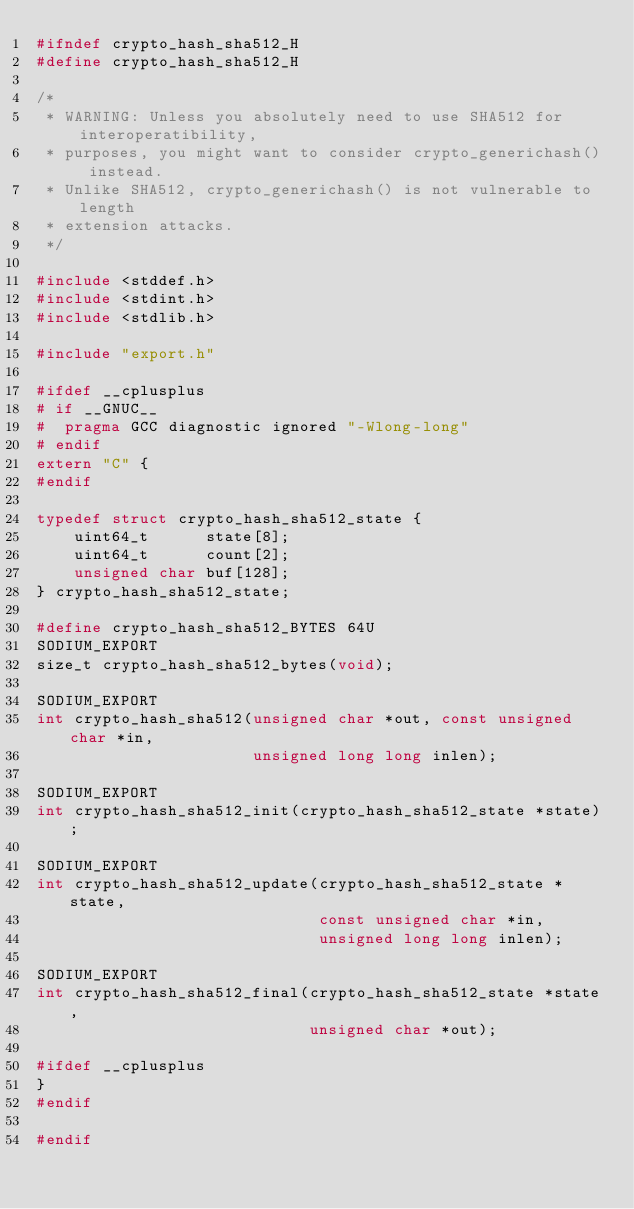Convert code to text. <code><loc_0><loc_0><loc_500><loc_500><_C_>#ifndef crypto_hash_sha512_H
#define crypto_hash_sha512_H

/*
 * WARNING: Unless you absolutely need to use SHA512 for interoperatibility,
 * purposes, you might want to consider crypto_generichash() instead.
 * Unlike SHA512, crypto_generichash() is not vulnerable to length
 * extension attacks.
 */

#include <stddef.h>
#include <stdint.h>
#include <stdlib.h>

#include "export.h"

#ifdef __cplusplus
# if __GNUC__
#  pragma GCC diagnostic ignored "-Wlong-long"
# endif
extern "C" {
#endif

typedef struct crypto_hash_sha512_state {
    uint64_t      state[8];
    uint64_t      count[2];
    unsigned char buf[128];
} crypto_hash_sha512_state;

#define crypto_hash_sha512_BYTES 64U
SODIUM_EXPORT
size_t crypto_hash_sha512_bytes(void);

SODIUM_EXPORT
int crypto_hash_sha512(unsigned char *out, const unsigned char *in,
                       unsigned long long inlen);

SODIUM_EXPORT
int crypto_hash_sha512_init(crypto_hash_sha512_state *state);

SODIUM_EXPORT
int crypto_hash_sha512_update(crypto_hash_sha512_state *state,
                              const unsigned char *in,
                              unsigned long long inlen);

SODIUM_EXPORT
int crypto_hash_sha512_final(crypto_hash_sha512_state *state,
                             unsigned char *out);

#ifdef __cplusplus
}
#endif

#endif
</code> 